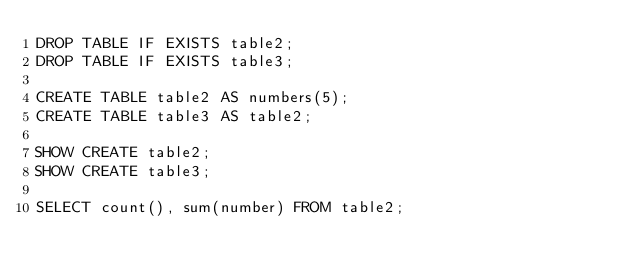<code> <loc_0><loc_0><loc_500><loc_500><_SQL_>DROP TABLE IF EXISTS table2;
DROP TABLE IF EXISTS table3;

CREATE TABLE table2 AS numbers(5);
CREATE TABLE table3 AS table2;

SHOW CREATE table2;
SHOW CREATE table3;

SELECT count(), sum(number) FROM table2;</code> 